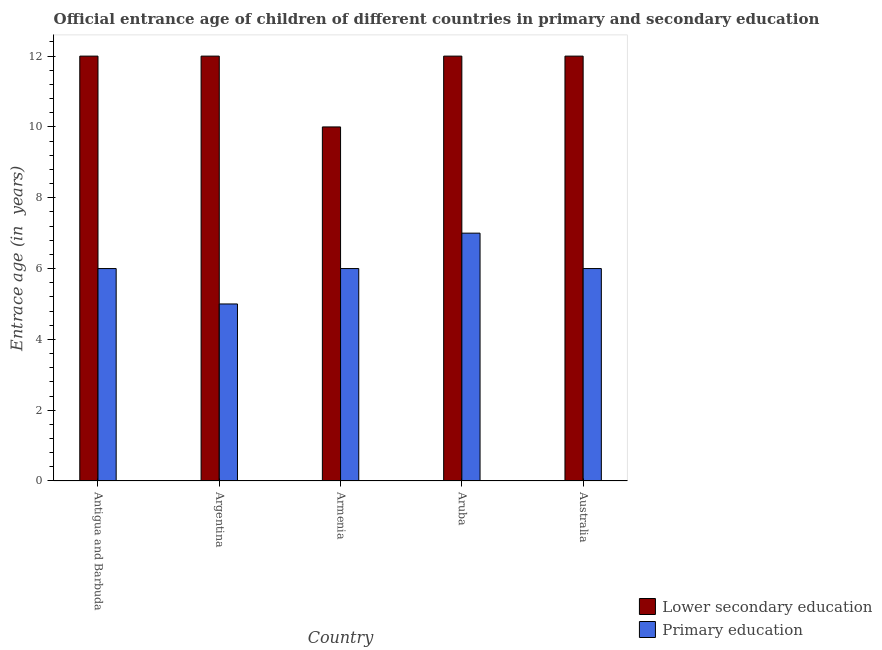How many different coloured bars are there?
Provide a succinct answer. 2. How many groups of bars are there?
Ensure brevity in your answer.  5. Are the number of bars on each tick of the X-axis equal?
Provide a short and direct response. Yes. How many bars are there on the 3rd tick from the right?
Make the answer very short. 2. What is the label of the 1st group of bars from the left?
Your answer should be very brief. Antigua and Barbuda. What is the entrance age of children in lower secondary education in Argentina?
Your answer should be very brief. 12. Across all countries, what is the maximum entrance age of children in lower secondary education?
Provide a short and direct response. 12. Across all countries, what is the minimum entrance age of children in lower secondary education?
Ensure brevity in your answer.  10. In which country was the entrance age of chiildren in primary education maximum?
Your answer should be compact. Aruba. What is the total entrance age of chiildren in primary education in the graph?
Provide a succinct answer. 30. What is the difference between the entrance age of chiildren in primary education in Armenia and that in Aruba?
Provide a short and direct response. -1. What is the difference between the entrance age of chiildren in primary education in Argentina and the entrance age of children in lower secondary education in Aruba?
Offer a terse response. -7. What is the average entrance age of chiildren in primary education per country?
Provide a succinct answer. 6. What is the difference between the entrance age of children in lower secondary education and entrance age of chiildren in primary education in Antigua and Barbuda?
Ensure brevity in your answer.  6. What is the ratio of the entrance age of children in lower secondary education in Antigua and Barbuda to that in Argentina?
Make the answer very short. 1. Is the entrance age of chiildren in primary education in Antigua and Barbuda less than that in Armenia?
Your response must be concise. No. Is the difference between the entrance age of chiildren in primary education in Antigua and Barbuda and Aruba greater than the difference between the entrance age of children in lower secondary education in Antigua and Barbuda and Aruba?
Give a very brief answer. No. What is the difference between the highest and the lowest entrance age of children in lower secondary education?
Your response must be concise. 2. What does the 1st bar from the left in Argentina represents?
Offer a very short reply. Lower secondary education. What does the 2nd bar from the right in Armenia represents?
Your answer should be compact. Lower secondary education. How many bars are there?
Ensure brevity in your answer.  10. Are all the bars in the graph horizontal?
Your answer should be very brief. No. What is the difference between two consecutive major ticks on the Y-axis?
Provide a succinct answer. 2. Does the graph contain grids?
Offer a very short reply. No. How many legend labels are there?
Your response must be concise. 2. What is the title of the graph?
Provide a succinct answer. Official entrance age of children of different countries in primary and secondary education. Does "RDB concessional" appear as one of the legend labels in the graph?
Offer a terse response. No. What is the label or title of the Y-axis?
Provide a short and direct response. Entrace age (in  years). What is the Entrace age (in  years) in Lower secondary education in Antigua and Barbuda?
Give a very brief answer. 12. What is the Entrace age (in  years) of Lower secondary education in Argentina?
Keep it short and to the point. 12. What is the Entrace age (in  years) in Primary education in Argentina?
Ensure brevity in your answer.  5. What is the Entrace age (in  years) in Lower secondary education in Armenia?
Provide a short and direct response. 10. What is the Entrace age (in  years) in Primary education in Aruba?
Your answer should be compact. 7. What is the Entrace age (in  years) of Primary education in Australia?
Offer a terse response. 6. Across all countries, what is the maximum Entrace age (in  years) of Primary education?
Keep it short and to the point. 7. What is the total Entrace age (in  years) of Lower secondary education in the graph?
Your answer should be very brief. 58. What is the total Entrace age (in  years) in Primary education in the graph?
Ensure brevity in your answer.  30. What is the difference between the Entrace age (in  years) of Lower secondary education in Antigua and Barbuda and that in Argentina?
Provide a succinct answer. 0. What is the difference between the Entrace age (in  years) of Primary education in Antigua and Barbuda and that in Armenia?
Ensure brevity in your answer.  0. What is the difference between the Entrace age (in  years) of Lower secondary education in Antigua and Barbuda and that in Australia?
Give a very brief answer. 0. What is the difference between the Entrace age (in  years) in Primary education in Argentina and that in Armenia?
Your response must be concise. -1. What is the difference between the Entrace age (in  years) in Lower secondary education in Argentina and that in Aruba?
Give a very brief answer. 0. What is the difference between the Entrace age (in  years) of Primary education in Argentina and that in Aruba?
Your answer should be very brief. -2. What is the difference between the Entrace age (in  years) of Lower secondary education in Armenia and that in Australia?
Give a very brief answer. -2. What is the difference between the Entrace age (in  years) in Primary education in Armenia and that in Australia?
Make the answer very short. 0. What is the difference between the Entrace age (in  years) of Lower secondary education in Aruba and that in Australia?
Provide a succinct answer. 0. What is the difference between the Entrace age (in  years) in Primary education in Aruba and that in Australia?
Offer a terse response. 1. What is the difference between the Entrace age (in  years) of Lower secondary education in Antigua and Barbuda and the Entrace age (in  years) of Primary education in Argentina?
Offer a very short reply. 7. What is the difference between the Entrace age (in  years) in Lower secondary education in Antigua and Barbuda and the Entrace age (in  years) in Primary education in Armenia?
Make the answer very short. 6. What is the difference between the Entrace age (in  years) of Lower secondary education in Antigua and Barbuda and the Entrace age (in  years) of Primary education in Australia?
Give a very brief answer. 6. What is the difference between the Entrace age (in  years) of Lower secondary education in Armenia and the Entrace age (in  years) of Primary education in Aruba?
Keep it short and to the point. 3. What is the average Entrace age (in  years) of Lower secondary education per country?
Offer a terse response. 11.6. What is the difference between the Entrace age (in  years) in Lower secondary education and Entrace age (in  years) in Primary education in Argentina?
Keep it short and to the point. 7. What is the difference between the Entrace age (in  years) in Lower secondary education and Entrace age (in  years) in Primary education in Aruba?
Your response must be concise. 5. What is the ratio of the Entrace age (in  years) in Lower secondary education in Antigua and Barbuda to that in Armenia?
Give a very brief answer. 1.2. What is the ratio of the Entrace age (in  years) in Primary education in Antigua and Barbuda to that in Armenia?
Offer a terse response. 1. What is the ratio of the Entrace age (in  years) of Lower secondary education in Antigua and Barbuda to that in Australia?
Your answer should be very brief. 1. What is the ratio of the Entrace age (in  years) of Lower secondary education in Argentina to that in Aruba?
Keep it short and to the point. 1. What is the ratio of the Entrace age (in  years) in Primary education in Argentina to that in Aruba?
Your response must be concise. 0.71. What is the ratio of the Entrace age (in  years) of Primary education in Argentina to that in Australia?
Your answer should be very brief. 0.83. What is the ratio of the Entrace age (in  years) in Lower secondary education in Armenia to that in Aruba?
Provide a short and direct response. 0.83. What is the ratio of the Entrace age (in  years) of Primary education in Armenia to that in Aruba?
Make the answer very short. 0.86. What is the ratio of the Entrace age (in  years) in Primary education in Armenia to that in Australia?
Offer a very short reply. 1. What is the ratio of the Entrace age (in  years) of Lower secondary education in Aruba to that in Australia?
Your answer should be very brief. 1. What is the difference between the highest and the second highest Entrace age (in  years) of Lower secondary education?
Keep it short and to the point. 0. What is the difference between the highest and the lowest Entrace age (in  years) of Lower secondary education?
Your answer should be very brief. 2. What is the difference between the highest and the lowest Entrace age (in  years) in Primary education?
Your response must be concise. 2. 